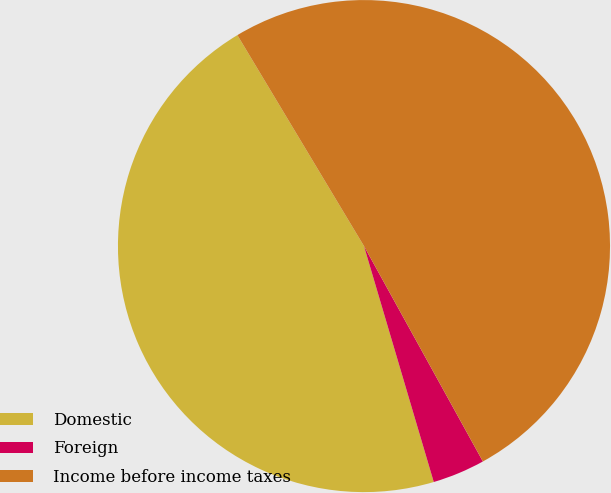Convert chart to OTSL. <chart><loc_0><loc_0><loc_500><loc_500><pie_chart><fcel>Domestic<fcel>Foreign<fcel>Income before income taxes<nl><fcel>45.97%<fcel>3.45%<fcel>50.57%<nl></chart> 